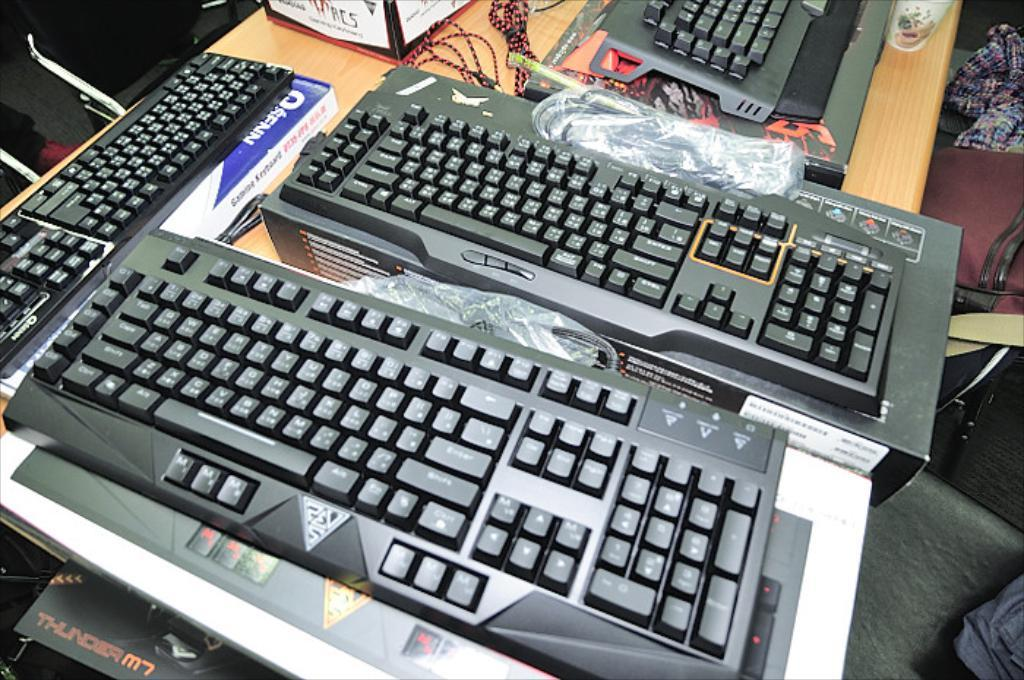<image>
Share a concise interpretation of the image provided. Several keyboards sit on a table and a box labeled Thunder peeks out from beneath. 